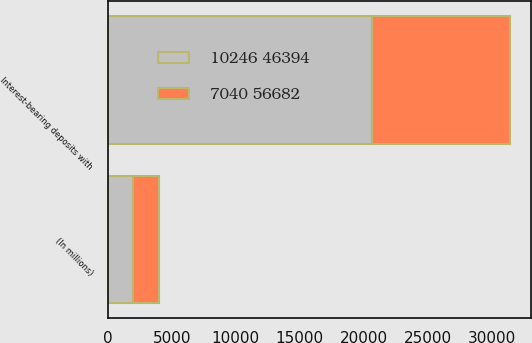Convert chart to OTSL. <chart><loc_0><loc_0><loc_500><loc_500><stacked_bar_chart><ecel><fcel>(In millions)<fcel>Interest-bearing deposits with<nl><fcel>10246 46394<fcel>2012<fcel>20665<nl><fcel>7040 56682<fcel>2011<fcel>10772<nl></chart> 